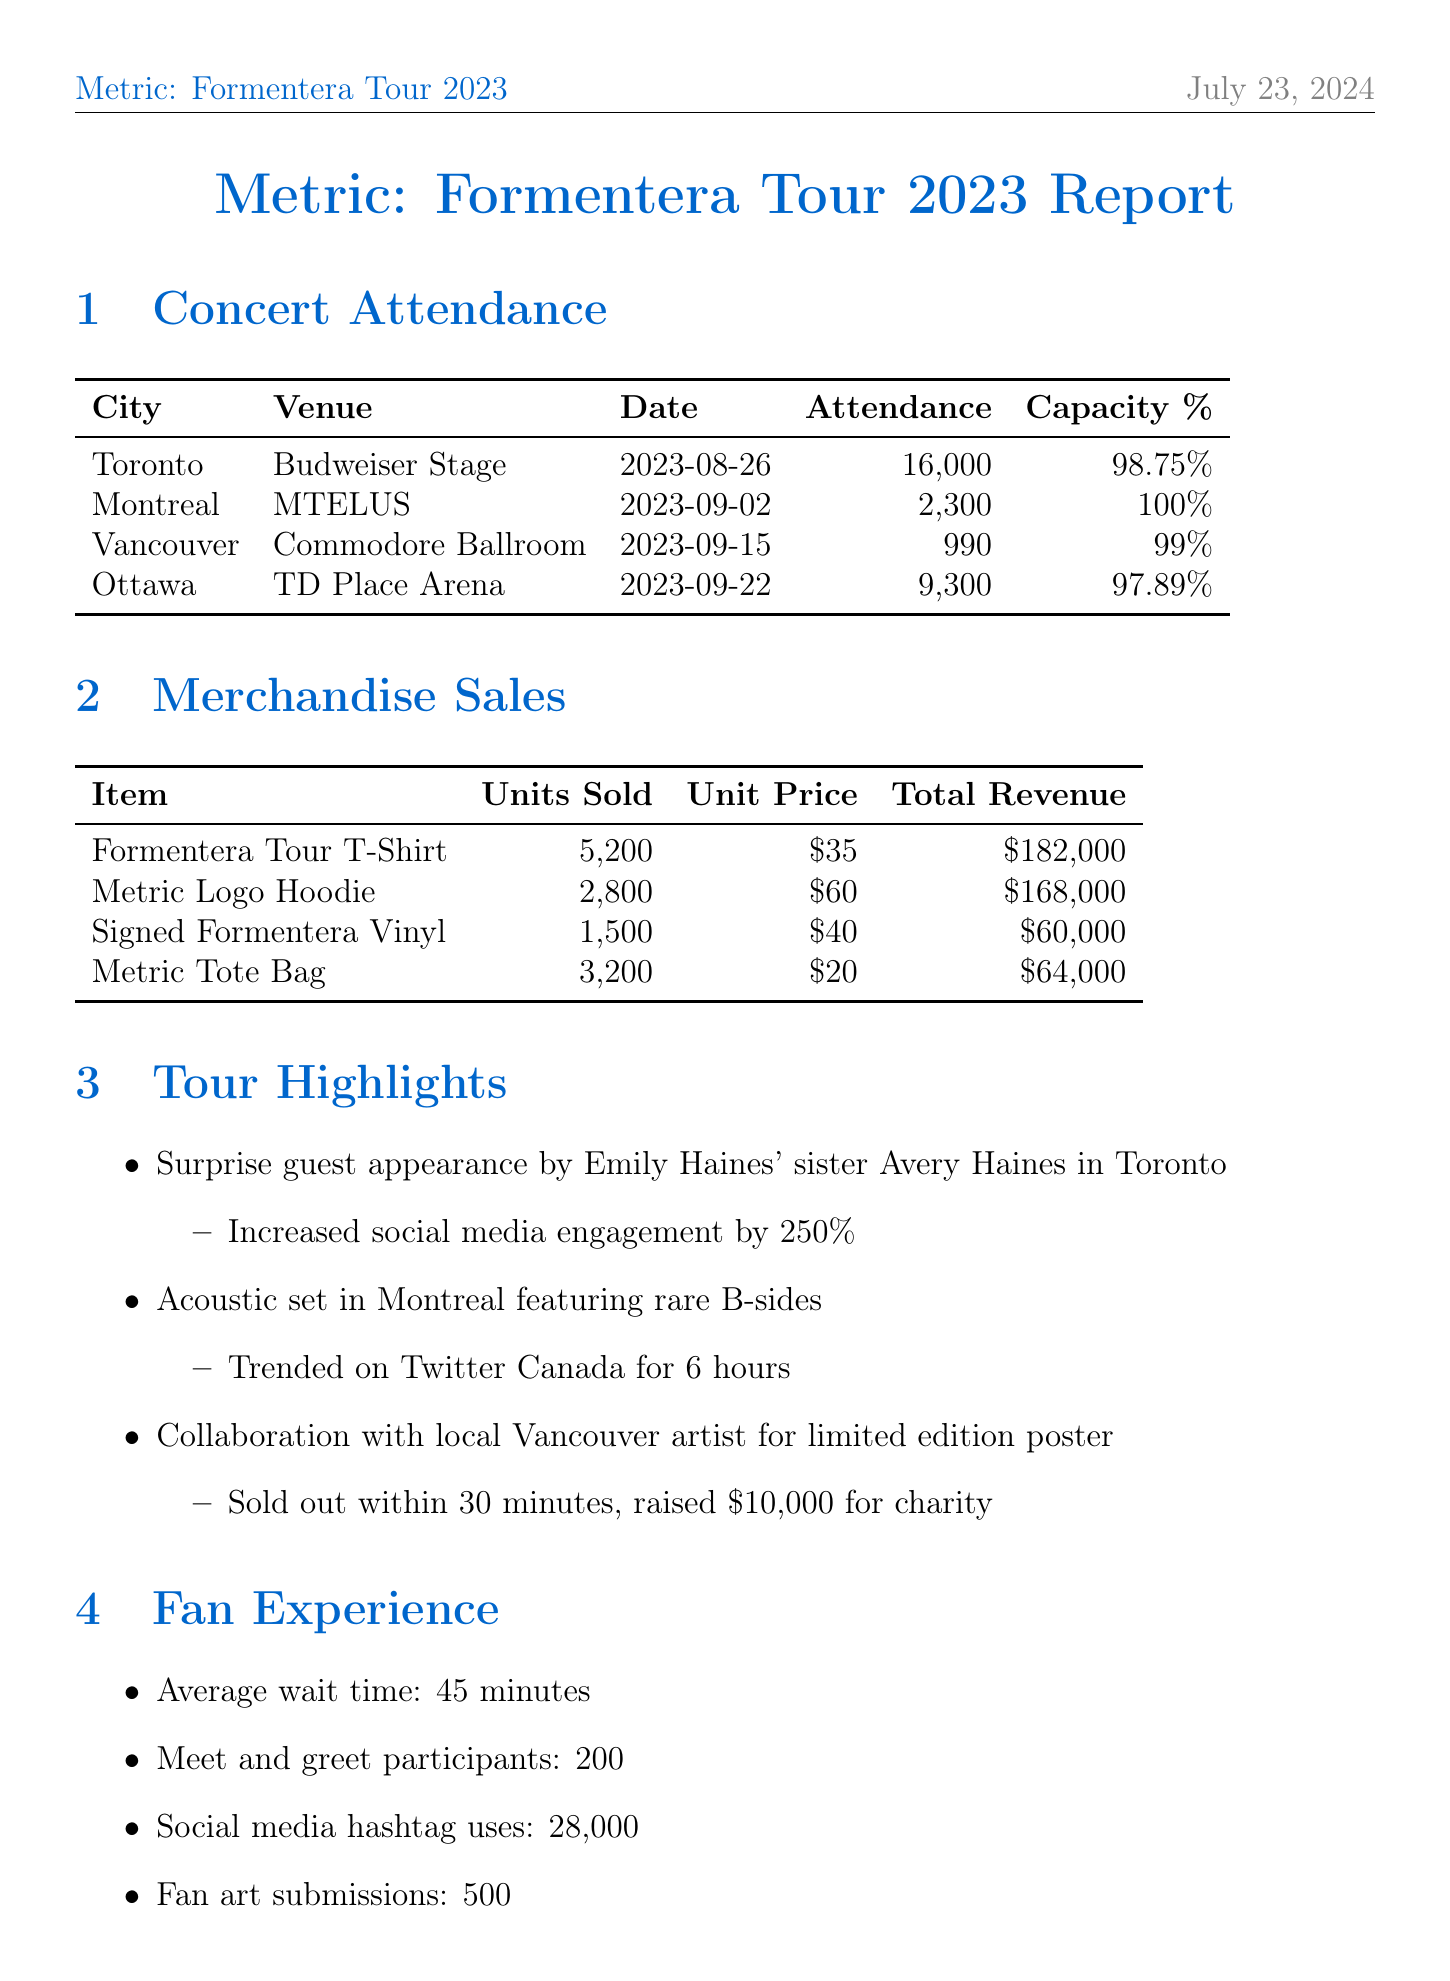What was the total attendance in Toronto? The attendance in Toronto is specified in the document as 16,000.
Answer: 16,000 Which city had a concert with 100% capacity? The city of Montreal had a concert where attendance reached 100% of its capacity.
Answer: Montreal How many total units of the Metric Logo Hoodie were sold? The document states that 2,800 units of the Metric Logo Hoodie were sold.
Answer: 2,800 What was the impact of the surprise guest appearance in Toronto? The surprise guest appearance increased social media engagement by 250%.
Answer: Increased social media engagement by 250% How much revenue was generated from the sales of the Formentera Tour T-Shirts? The total revenue from the Formentera Tour T-Shirts is listed as $182,000.
Answer: $182,000 What was the average wait time reported by fans? The report mentions that the average wait time for fans was 45 minutes.
Answer: 45 minutes Which environmental initiative involved reusable items? The environmental initiative involved selling 8,500 reusable water bottles.
Answer: Reusable water bottles sold What date did the concert in Vancouver take place? The concert in Vancouver occurred on September 15, 2023.
Answer: 2023-09-15 How much was donated for carbon offset initiatives? The document states that $15,000 was donated for carbon offset initiatives.
Answer: $15,000 